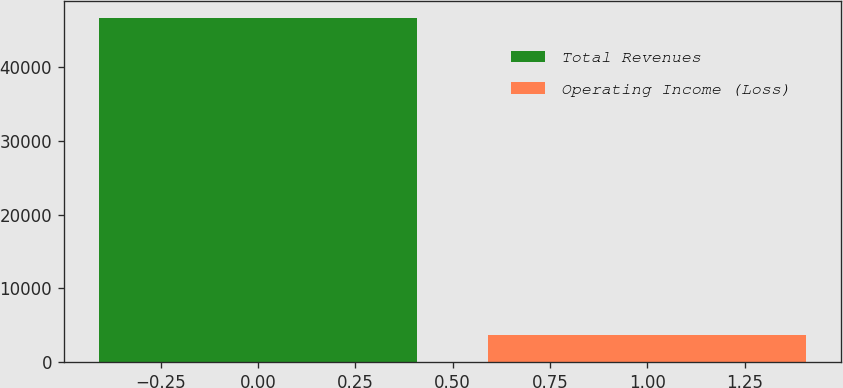Convert chart to OTSL. <chart><loc_0><loc_0><loc_500><loc_500><bar_chart><fcel>Total Revenues<fcel>Operating Income (Loss)<nl><fcel>46723<fcel>3648<nl></chart> 